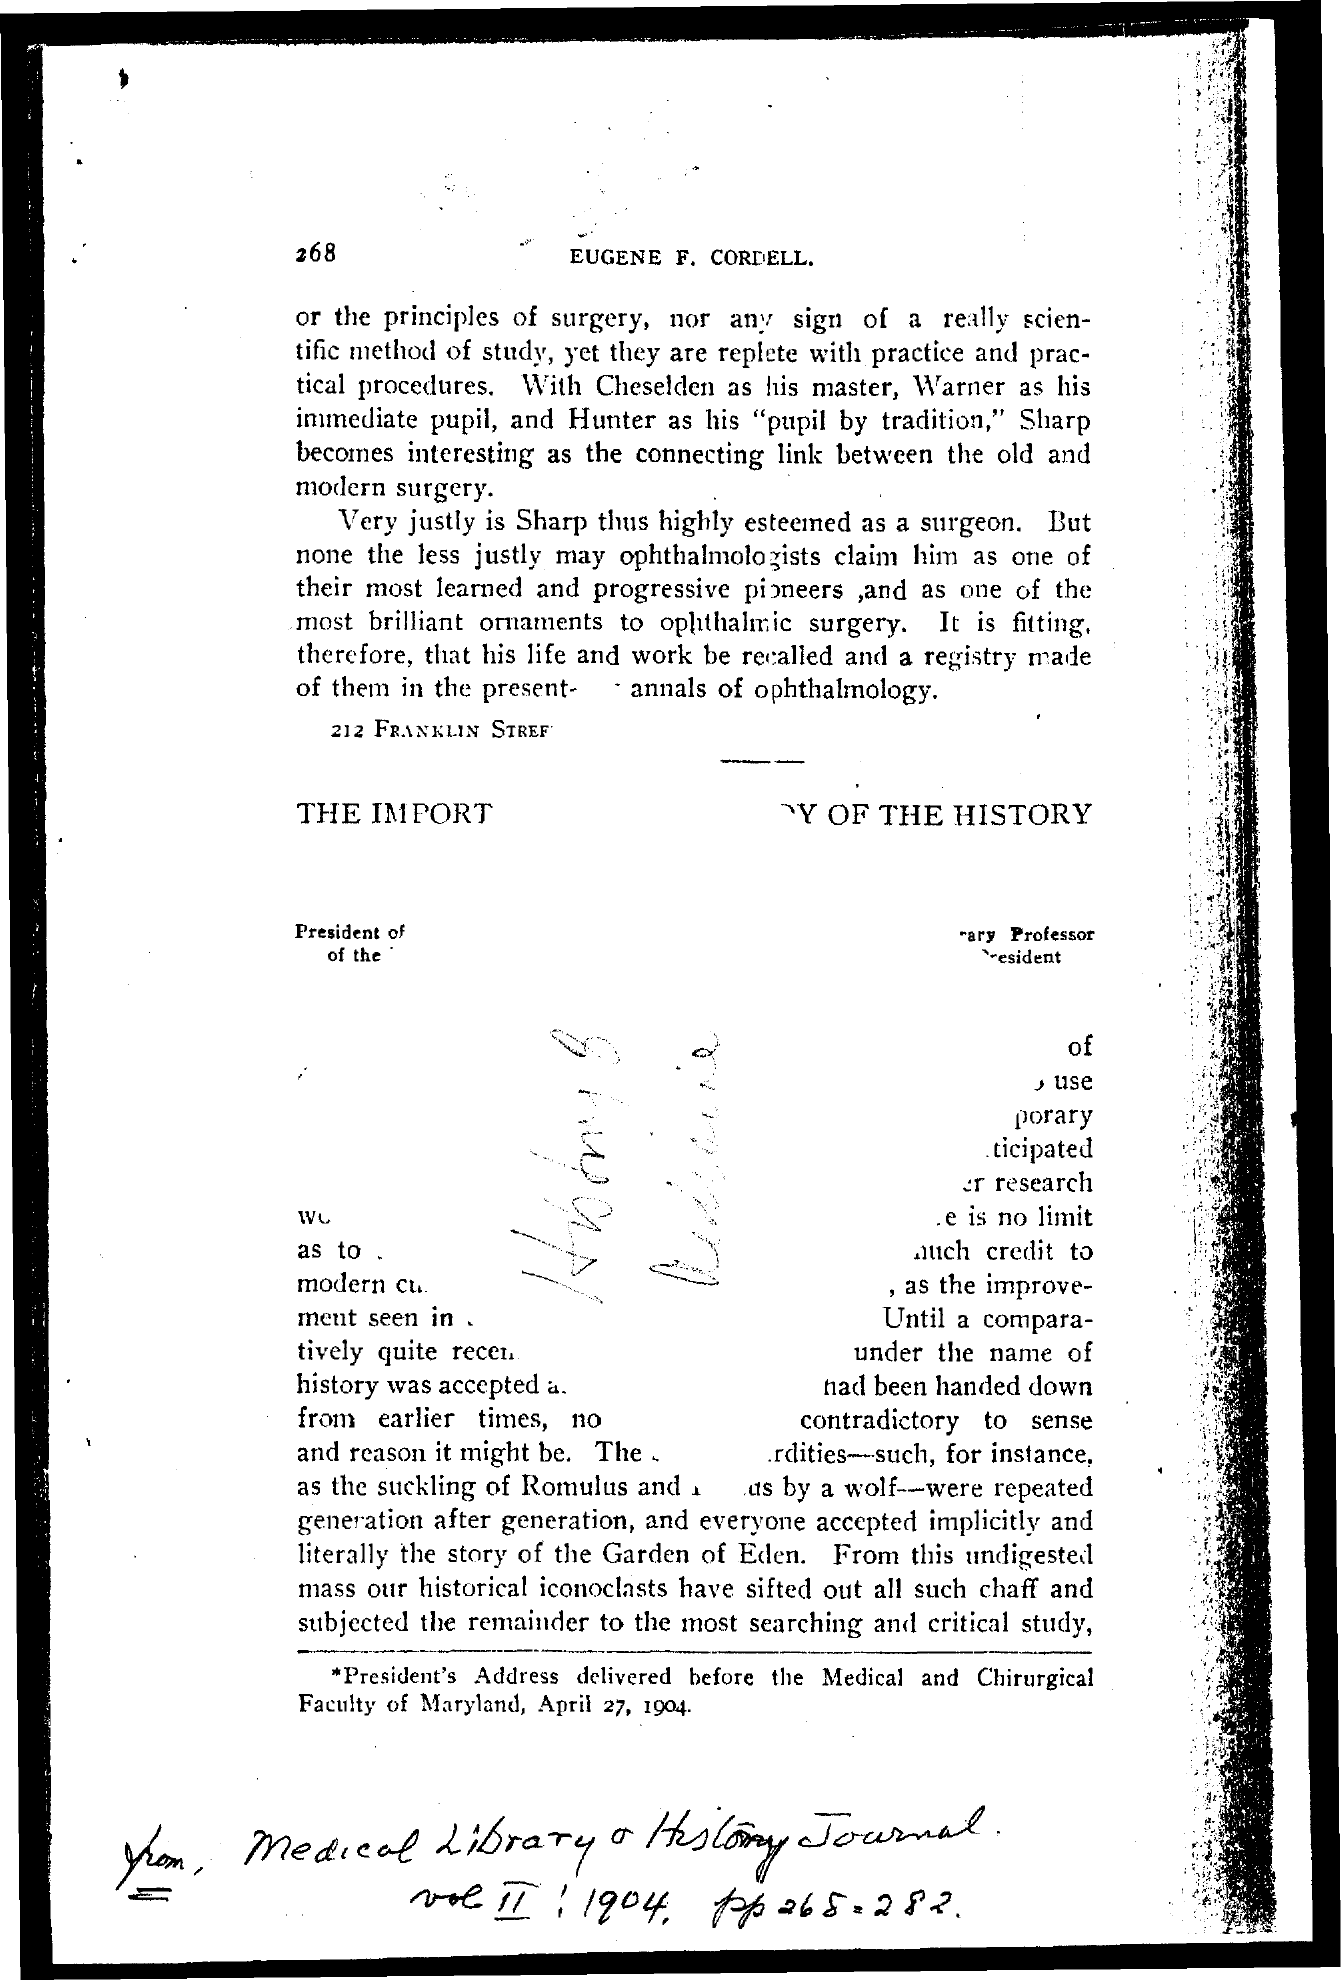What is the Page Number?
Provide a short and direct response. 268. 